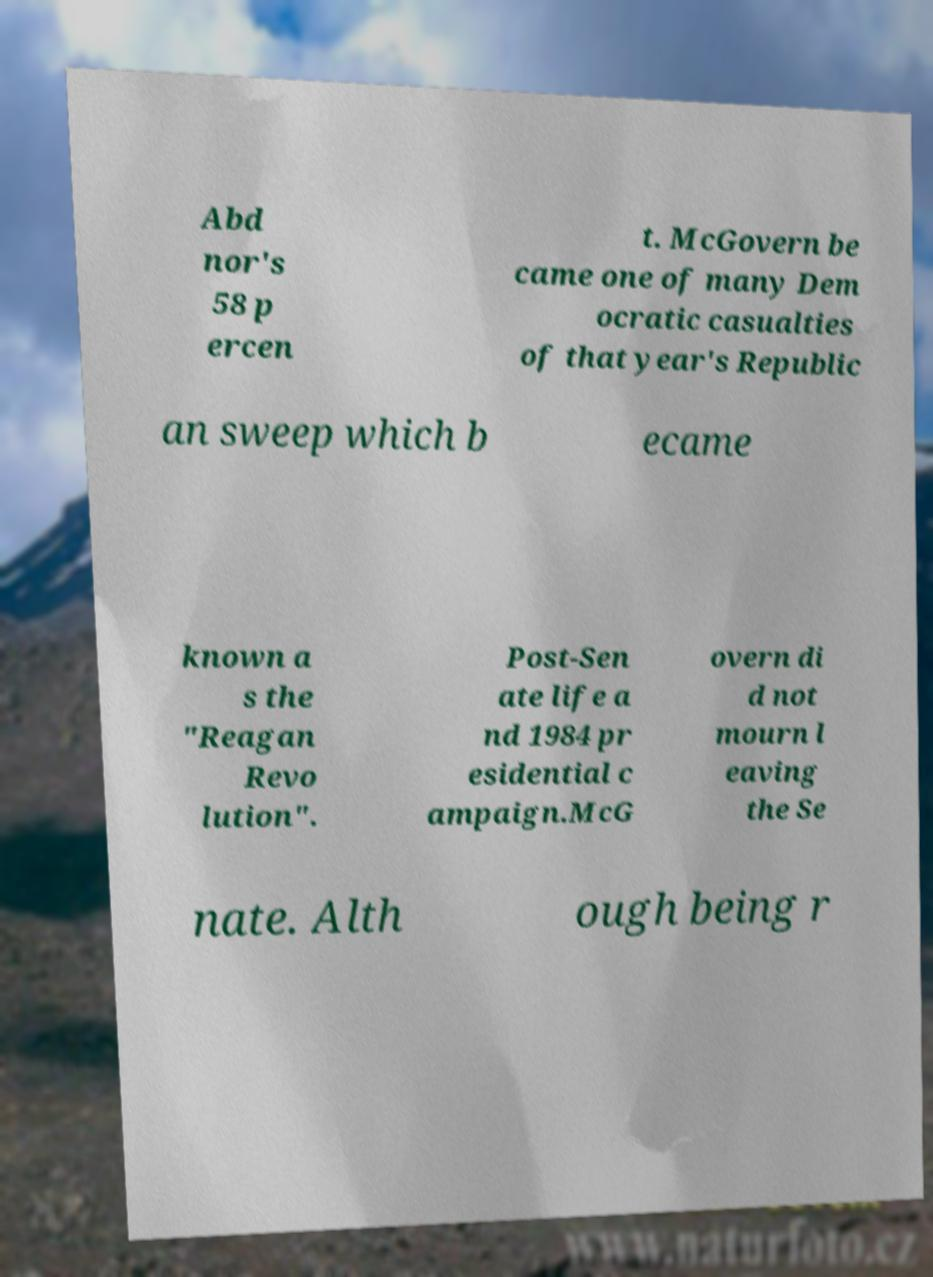Can you accurately transcribe the text from the provided image for me? Abd nor's 58 p ercen t. McGovern be came one of many Dem ocratic casualties of that year's Republic an sweep which b ecame known a s the "Reagan Revo lution". Post-Sen ate life a nd 1984 pr esidential c ampaign.McG overn di d not mourn l eaving the Se nate. Alth ough being r 